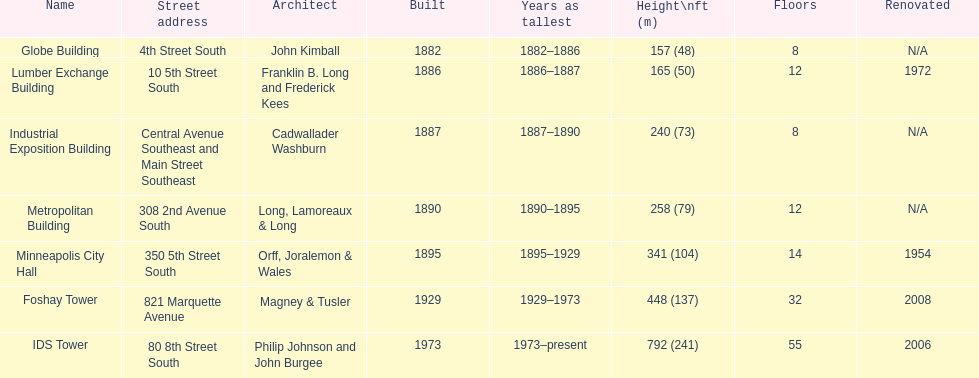Which structure has an identical number of floors as the lumber exchange building? Metropolitan Building. 